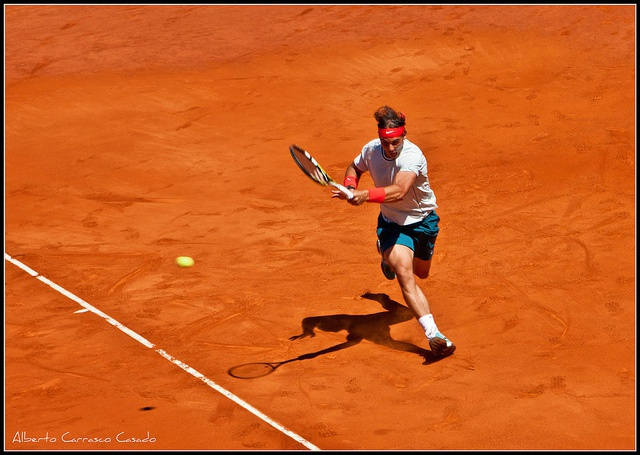Describe the objects in this image and their specific colors. I can see people in black, red, maroon, and white tones, tennis racket in black, brown, maroon, and white tones, and sports ball in black, khaki, and orange tones in this image. 